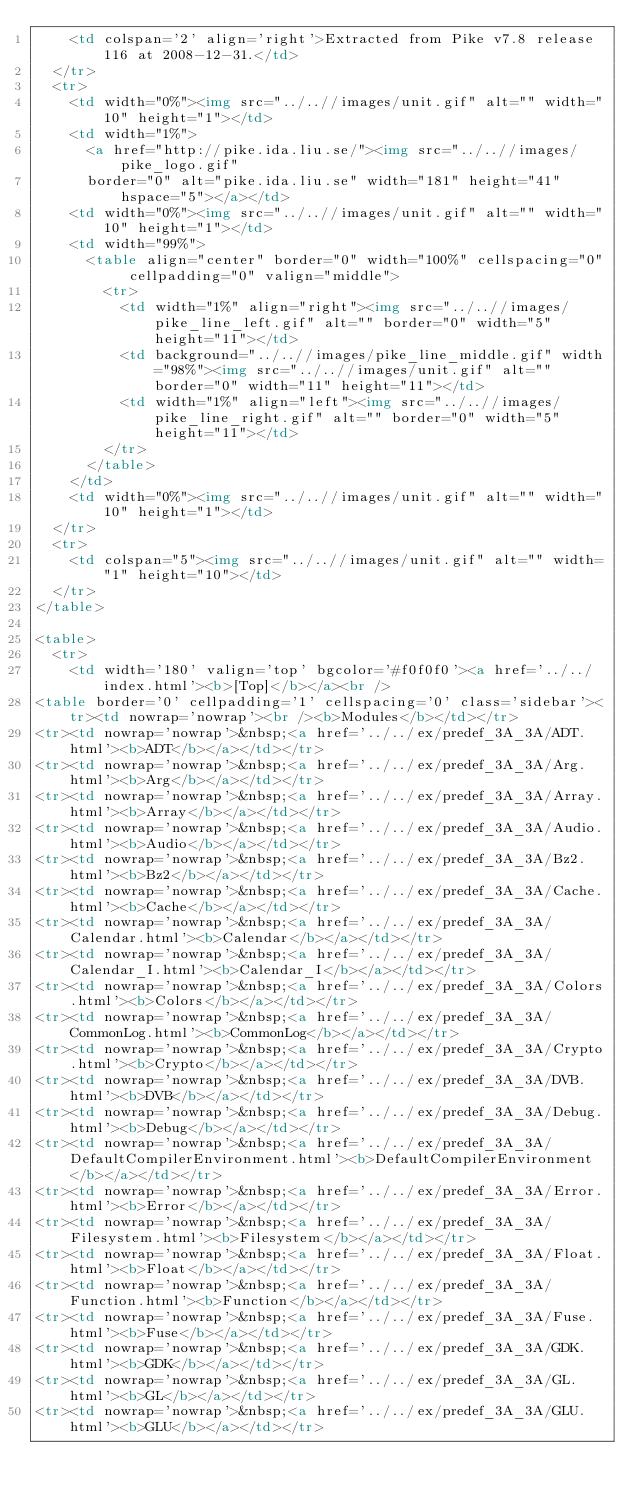Convert code to text. <code><loc_0><loc_0><loc_500><loc_500><_HTML_>    <td colspan='2' align='right'>Extracted from Pike v7.8 release 116 at 2008-12-31.</td>
  </tr>
  <tr>
    <td width="0%"><img src="../..//images/unit.gif" alt="" width="10" height="1"></td>
    <td width="1%">
      <a href="http://pike.ida.liu.se/"><img src="../..//images/pike_logo.gif"
      border="0" alt="pike.ida.liu.se" width="181" height="41" hspace="5"></a></td>
    <td width="0%"><img src="../..//images/unit.gif" alt="" width="10" height="1"></td>
    <td width="99%">
      <table align="center" border="0" width="100%" cellspacing="0" cellpadding="0" valign="middle">
        <tr>
          <td width="1%" align="right"><img src="../..//images/pike_line_left.gif" alt="" border="0" width="5" height="11"></td>
          <td background="../..//images/pike_line_middle.gif" width="98%"><img src="../..//images/unit.gif" alt="" border="0" width="11" height="11"></td>
          <td width="1%" align="left"><img src="../..//images/pike_line_right.gif" alt="" border="0" width="5" height="11"></td>
        </tr>
      </table>
    </td>
    <td width="0%"><img src="../..//images/unit.gif" alt="" width="10" height="1"></td>
  </tr>
  <tr>
    <td colspan="5"><img src="../..//images/unit.gif" alt="" width="1" height="10"></td>
  </tr>
</table>

<table>
  <tr>
    <td width='180' valign='top' bgcolor='#f0f0f0'><a href='../../index.html'><b>[Top]</b></a><br />
<table border='0' cellpadding='1' cellspacing='0' class='sidebar'><tr><td nowrap='nowrap'><br /><b>Modules</b></td></tr>
<tr><td nowrap='nowrap'>&nbsp;<a href='../../ex/predef_3A_3A/ADT.html'><b>ADT</b></a></td></tr>
<tr><td nowrap='nowrap'>&nbsp;<a href='../../ex/predef_3A_3A/Arg.html'><b>Arg</b></a></td></tr>
<tr><td nowrap='nowrap'>&nbsp;<a href='../../ex/predef_3A_3A/Array.html'><b>Array</b></a></td></tr>
<tr><td nowrap='nowrap'>&nbsp;<a href='../../ex/predef_3A_3A/Audio.html'><b>Audio</b></a></td></tr>
<tr><td nowrap='nowrap'>&nbsp;<a href='../../ex/predef_3A_3A/Bz2.html'><b>Bz2</b></a></td></tr>
<tr><td nowrap='nowrap'>&nbsp;<a href='../../ex/predef_3A_3A/Cache.html'><b>Cache</b></a></td></tr>
<tr><td nowrap='nowrap'>&nbsp;<a href='../../ex/predef_3A_3A/Calendar.html'><b>Calendar</b></a></td></tr>
<tr><td nowrap='nowrap'>&nbsp;<a href='../../ex/predef_3A_3A/Calendar_I.html'><b>Calendar_I</b></a></td></tr>
<tr><td nowrap='nowrap'>&nbsp;<a href='../../ex/predef_3A_3A/Colors.html'><b>Colors</b></a></td></tr>
<tr><td nowrap='nowrap'>&nbsp;<a href='../../ex/predef_3A_3A/CommonLog.html'><b>CommonLog</b></a></td></tr>
<tr><td nowrap='nowrap'>&nbsp;<a href='../../ex/predef_3A_3A/Crypto.html'><b>Crypto</b></a></td></tr>
<tr><td nowrap='nowrap'>&nbsp;<a href='../../ex/predef_3A_3A/DVB.html'><b>DVB</b></a></td></tr>
<tr><td nowrap='nowrap'>&nbsp;<a href='../../ex/predef_3A_3A/Debug.html'><b>Debug</b></a></td></tr>
<tr><td nowrap='nowrap'>&nbsp;<a href='../../ex/predef_3A_3A/DefaultCompilerEnvironment.html'><b>DefaultCompilerEnvironment</b></a></td></tr>
<tr><td nowrap='nowrap'>&nbsp;<a href='../../ex/predef_3A_3A/Error.html'><b>Error</b></a></td></tr>
<tr><td nowrap='nowrap'>&nbsp;<a href='../../ex/predef_3A_3A/Filesystem.html'><b>Filesystem</b></a></td></tr>
<tr><td nowrap='nowrap'>&nbsp;<a href='../../ex/predef_3A_3A/Float.html'><b>Float</b></a></td></tr>
<tr><td nowrap='nowrap'>&nbsp;<a href='../../ex/predef_3A_3A/Function.html'><b>Function</b></a></td></tr>
<tr><td nowrap='nowrap'>&nbsp;<a href='../../ex/predef_3A_3A/Fuse.html'><b>Fuse</b></a></td></tr>
<tr><td nowrap='nowrap'>&nbsp;<a href='../../ex/predef_3A_3A/GDK.html'><b>GDK</b></a></td></tr>
<tr><td nowrap='nowrap'>&nbsp;<a href='../../ex/predef_3A_3A/GL.html'><b>GL</b></a></td></tr>
<tr><td nowrap='nowrap'>&nbsp;<a href='../../ex/predef_3A_3A/GLU.html'><b>GLU</b></a></td></tr></code> 